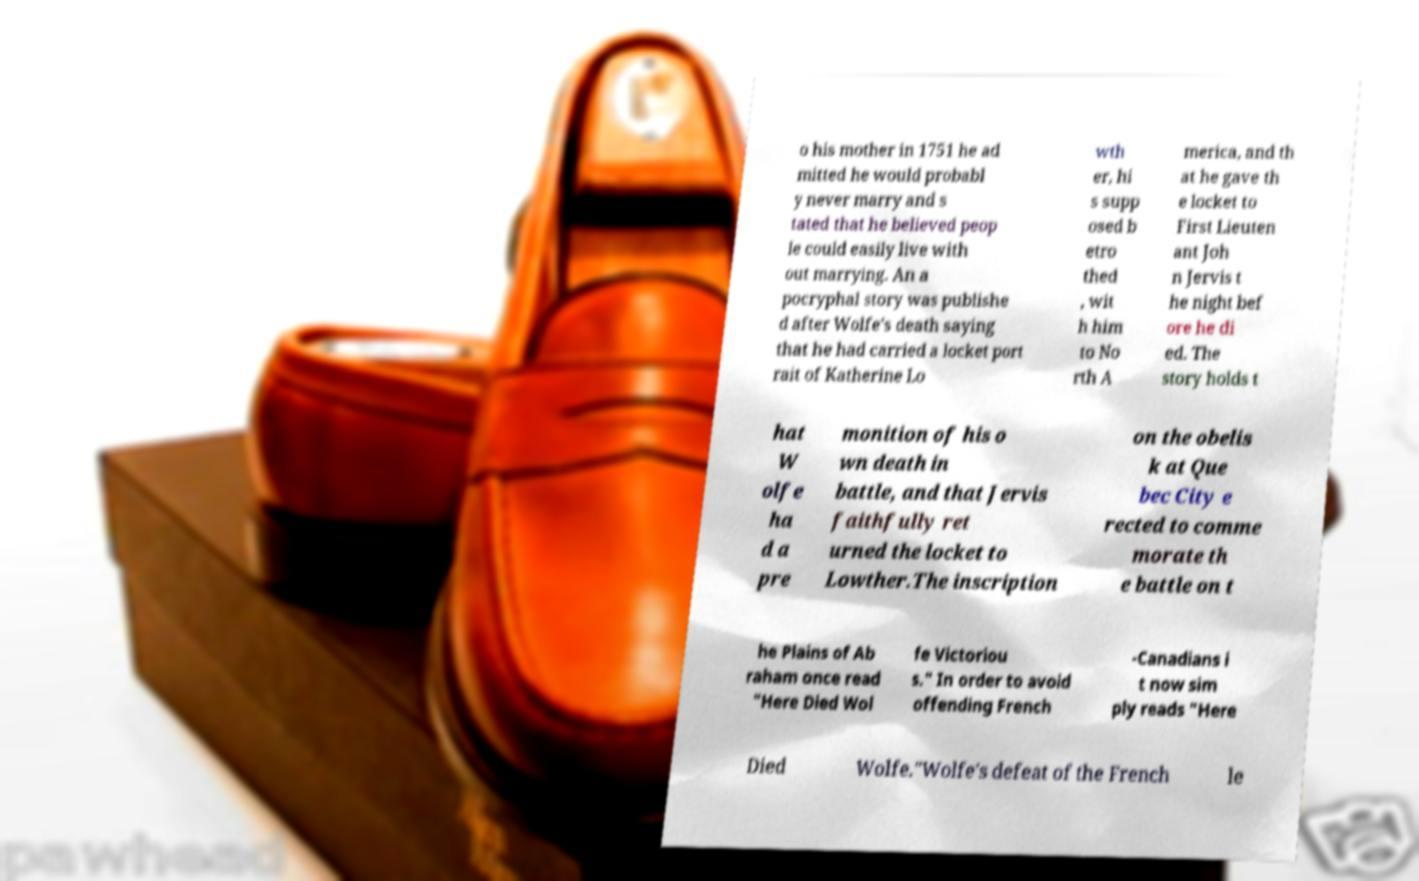There's text embedded in this image that I need extracted. Can you transcribe it verbatim? o his mother in 1751 he ad mitted he would probabl y never marry and s tated that he believed peop le could easily live with out marrying. An a pocryphal story was publishe d after Wolfe's death saying that he had carried a locket port rait of Katherine Lo wth er, hi s supp osed b etro thed , wit h him to No rth A merica, and th at he gave th e locket to First Lieuten ant Joh n Jervis t he night bef ore he di ed. The story holds t hat W olfe ha d a pre monition of his o wn death in battle, and that Jervis faithfully ret urned the locket to Lowther.The inscription on the obelis k at Que bec City e rected to comme morate th e battle on t he Plains of Ab raham once read "Here Died Wol fe Victoriou s." In order to avoid offending French -Canadians i t now sim ply reads "Here Died Wolfe."Wolfe's defeat of the French le 